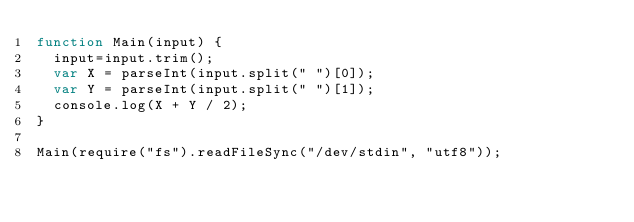Convert code to text. <code><loc_0><loc_0><loc_500><loc_500><_JavaScript_>function Main(input) {
  input=input.trim();
  var X = parseInt(input.split(" ")[0]);
  var Y = parseInt(input.split(" ")[1]);
  console.log(X + Y / 2);
}

Main(require("fs").readFileSync("/dev/stdin", "utf8"));
</code> 